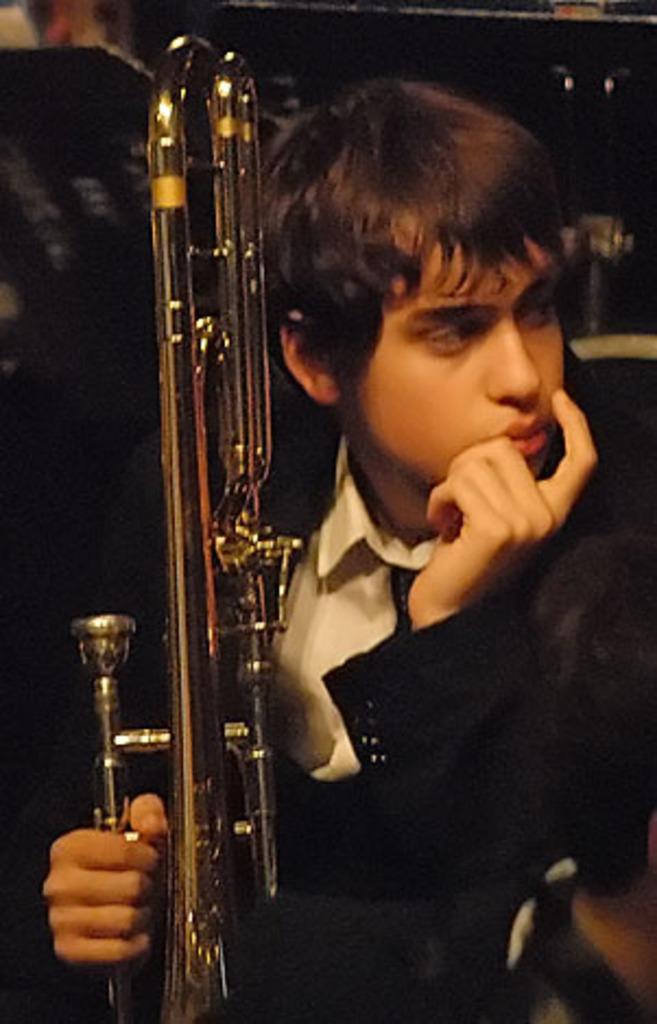How would you summarize this image in a sentence or two? In this image, we can see a boy sitting and holding a musical instrument. 